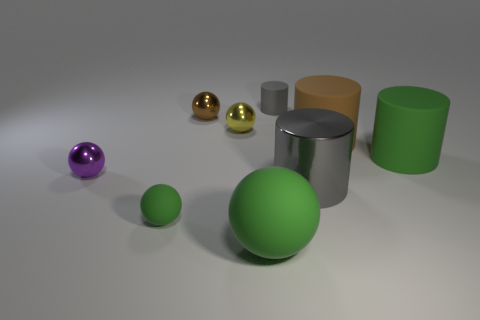Does the big brown rubber object have the same shape as the gray object in front of the tiny brown sphere?
Provide a short and direct response. Yes. What material is the small cylinder that is the same color as the big metal thing?
Your answer should be very brief. Rubber. Does the tiny rubber object behind the small green ball have the same shape as the green rubber thing right of the large rubber sphere?
Offer a terse response. Yes. What color is the large cylinder that is behind the green cylinder?
Your answer should be very brief. Brown. What number of other objects are the same material as the tiny cylinder?
Ensure brevity in your answer.  4. Is the number of gray things in front of the brown metallic thing greater than the number of small gray rubber things in front of the tiny yellow ball?
Your response must be concise. Yes. How many small rubber balls are left of the purple metallic object?
Offer a terse response. 0. Does the small brown thing have the same material as the gray object in front of the yellow metallic sphere?
Your answer should be very brief. Yes. Do the large gray cylinder and the large green cylinder have the same material?
Your response must be concise. No. Are there any yellow objects to the left of the gray object that is behind the big brown matte object?
Your response must be concise. Yes. 